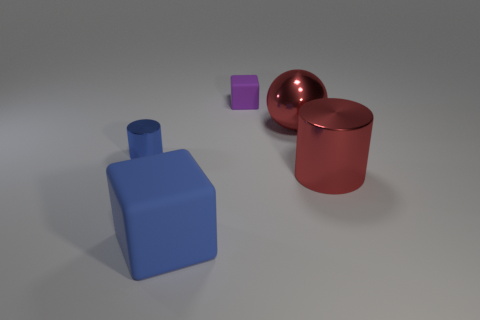What shape is the metallic thing that is the same color as the big matte cube?
Your answer should be very brief. Cylinder. There is a small thing right of the big blue matte cube; is its shape the same as the blue matte object?
Keep it short and to the point. Yes. Are any big spheres visible?
Offer a very short reply. Yes. Are there more things that are behind the large red shiny cylinder than blue shiny things?
Keep it short and to the point. Yes. There is a big sphere; are there any tiny blue metallic cylinders in front of it?
Offer a very short reply. Yes. Do the purple block and the red ball have the same size?
Provide a succinct answer. No. There is another matte object that is the same shape as the large rubber thing; what is its size?
Your answer should be very brief. Small. Is there anything else that has the same size as the sphere?
Provide a short and direct response. Yes. The purple object that is to the right of the shiny thing left of the large rubber block is made of what material?
Make the answer very short. Rubber. Is the purple rubber thing the same shape as the large blue object?
Offer a terse response. Yes. 